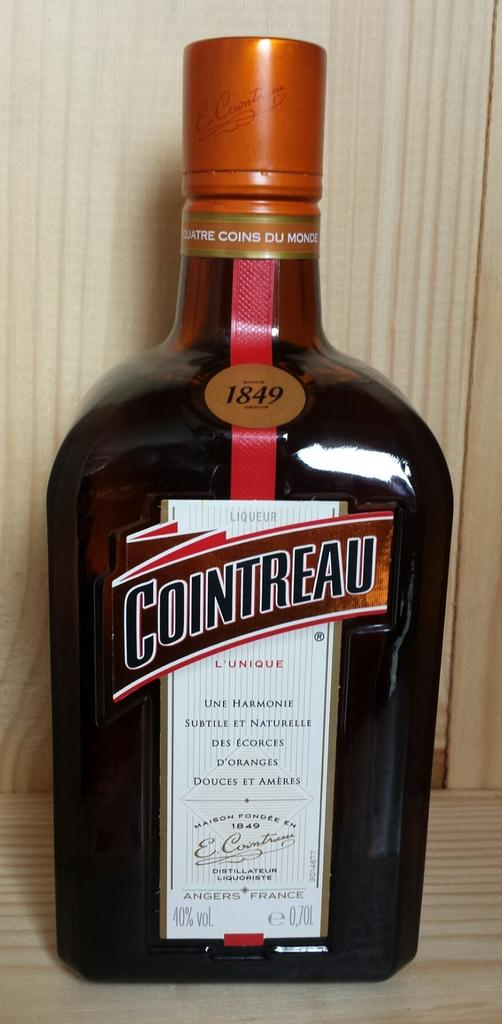<image>
Present a compact description of the photo's key features. a bottle of COINTREAU  L' UNIQUE liquor, with more French words on it. 